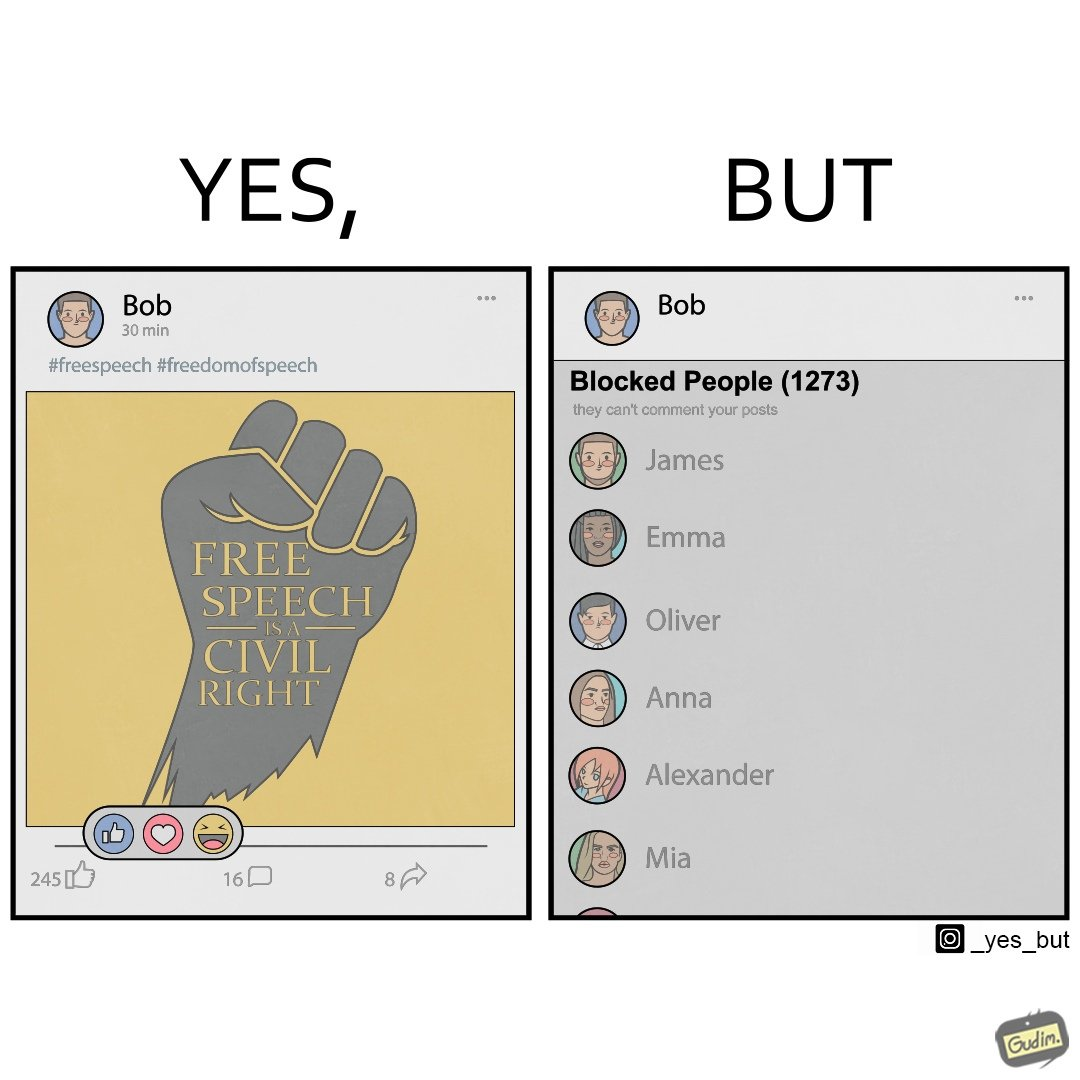What is shown in the left half versus the right half of this image? In the left part of the image: It is a social media post by "Bob" showing his support for free speech as a civil right In the right part of the image: It is a list of all the prople "Bob" has blocked on his contacts list 